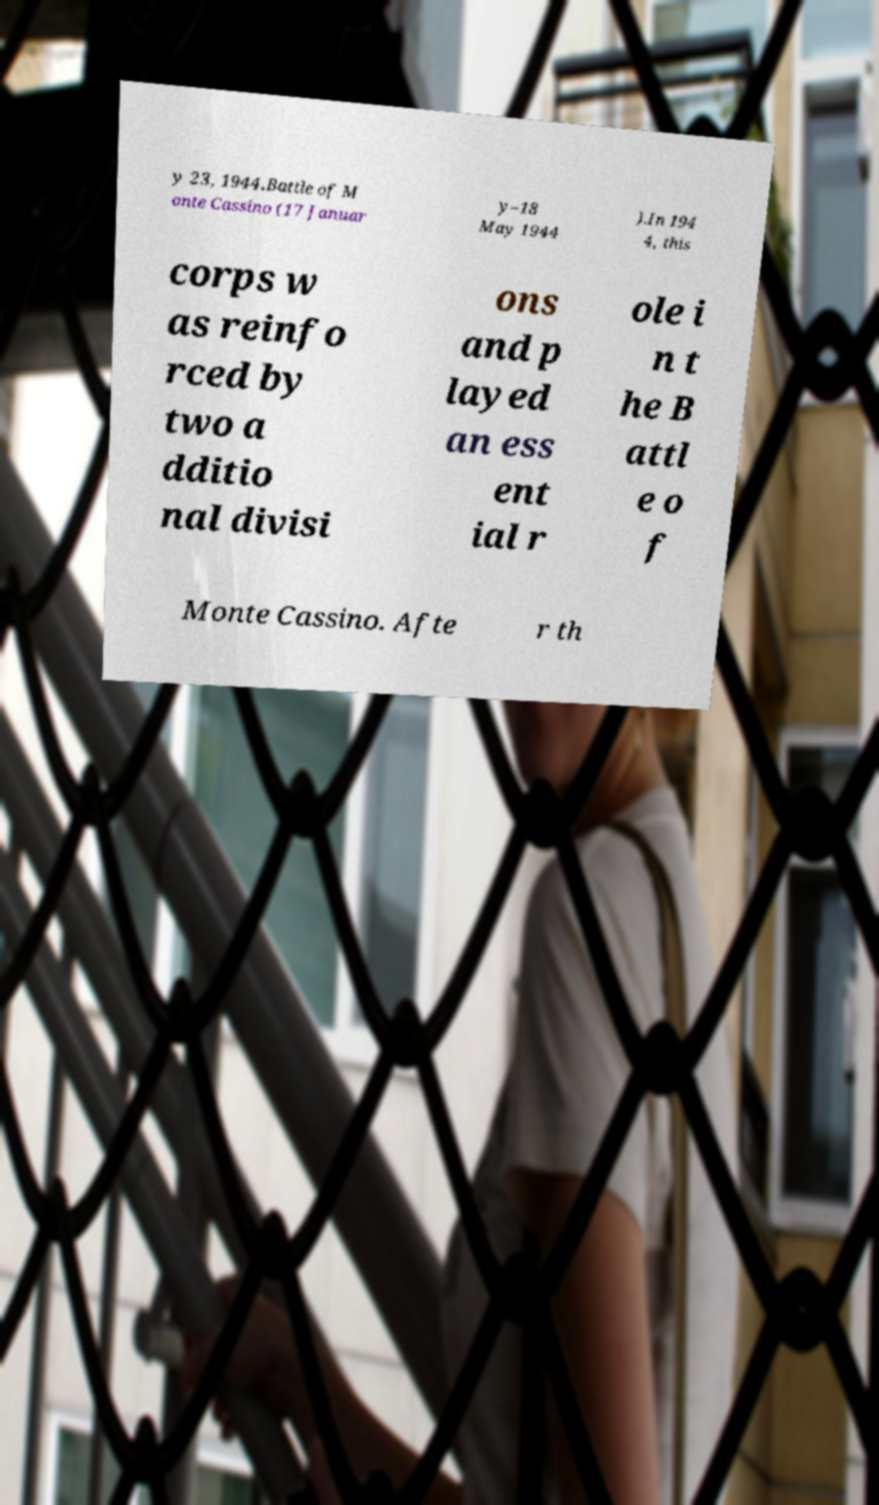Could you extract and type out the text from this image? y 23, 1944.Battle of M onte Cassino (17 Januar y–18 May 1944 ).In 194 4, this corps w as reinfo rced by two a dditio nal divisi ons and p layed an ess ent ial r ole i n t he B attl e o f Monte Cassino. Afte r th 